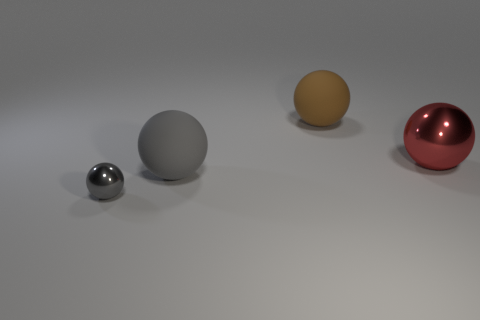There is a object that is to the right of the big brown rubber sphere; how many brown matte spheres are right of it?
Your answer should be compact. 0. There is a sphere that is to the right of the small gray sphere and in front of the red sphere; how big is it?
Your response must be concise. Large. Are there any gray shiny balls that have the same size as the brown matte object?
Provide a succinct answer. No. Is the number of large red metal objects to the left of the small gray object greater than the number of big things that are left of the big brown sphere?
Keep it short and to the point. No. Do the red sphere and the big thing behind the big red metal object have the same material?
Your response must be concise. No. There is a big matte thing that is right of the matte thing that is in front of the brown matte object; what number of red metallic spheres are behind it?
Your response must be concise. 0. There is a big metal thing; is it the same shape as the gray thing that is to the right of the tiny gray sphere?
Offer a very short reply. Yes. There is a thing that is both behind the small gray shiny thing and in front of the large red metallic thing; what is its color?
Ensure brevity in your answer.  Gray. There is a large sphere behind the ball on the right side of the large brown matte sphere behind the gray shiny ball; what is it made of?
Your answer should be compact. Rubber. What is the material of the tiny gray ball?
Ensure brevity in your answer.  Metal. 